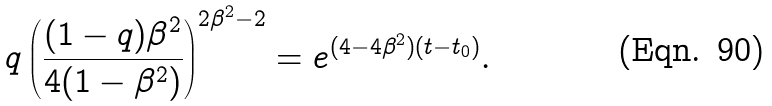Convert formula to latex. <formula><loc_0><loc_0><loc_500><loc_500>q \left ( \frac { ( 1 - q ) \beta ^ { 2 } } { 4 ( 1 - \beta ^ { 2 } ) } \right ) ^ { 2 \beta ^ { 2 } - 2 } = e ^ { ( 4 - 4 \beta ^ { 2 } ) ( t - t _ { 0 } ) } .</formula> 